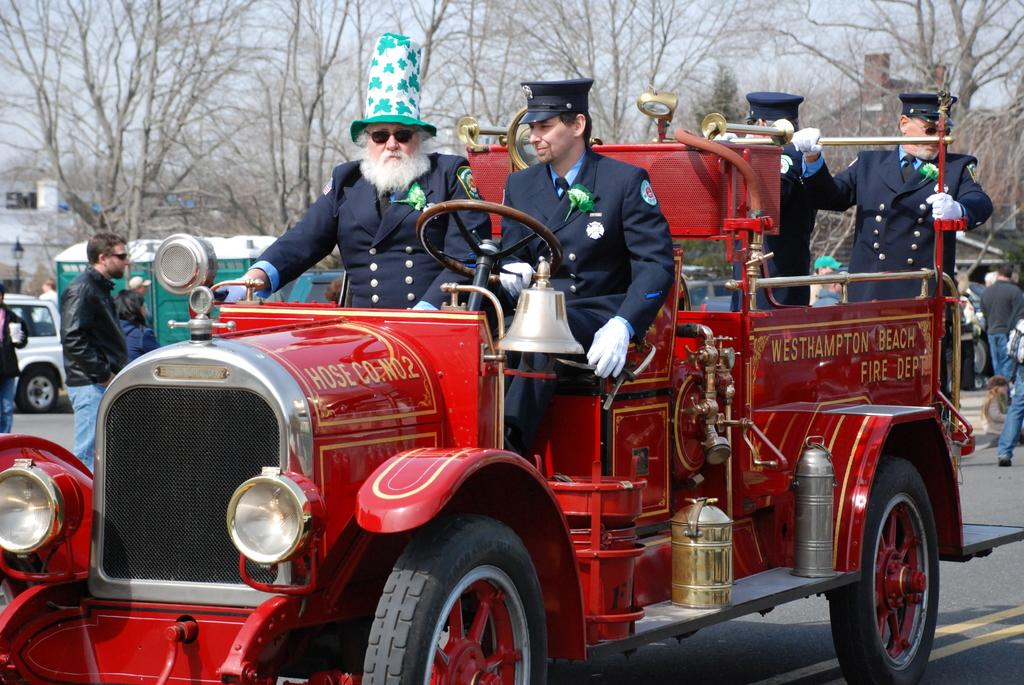Who or what can be seen in the image? There are people in the image. What else is present in the image besides people? There are vehicles, buildings, a street lamp, and trees in the image. What is visible at the top of the image? The sky is visible at the top of the image. Can you tell me what type of sea creature is swimming in the image? There is no sea creature present in the image; it features people, vehicles, buildings, a street lamp, trees, and the sky. What treatment is being administered to the people in the image? There is no treatment being administered in the image; it simply shows people, vehicles, buildings, a street lamp, trees, and the sky. 